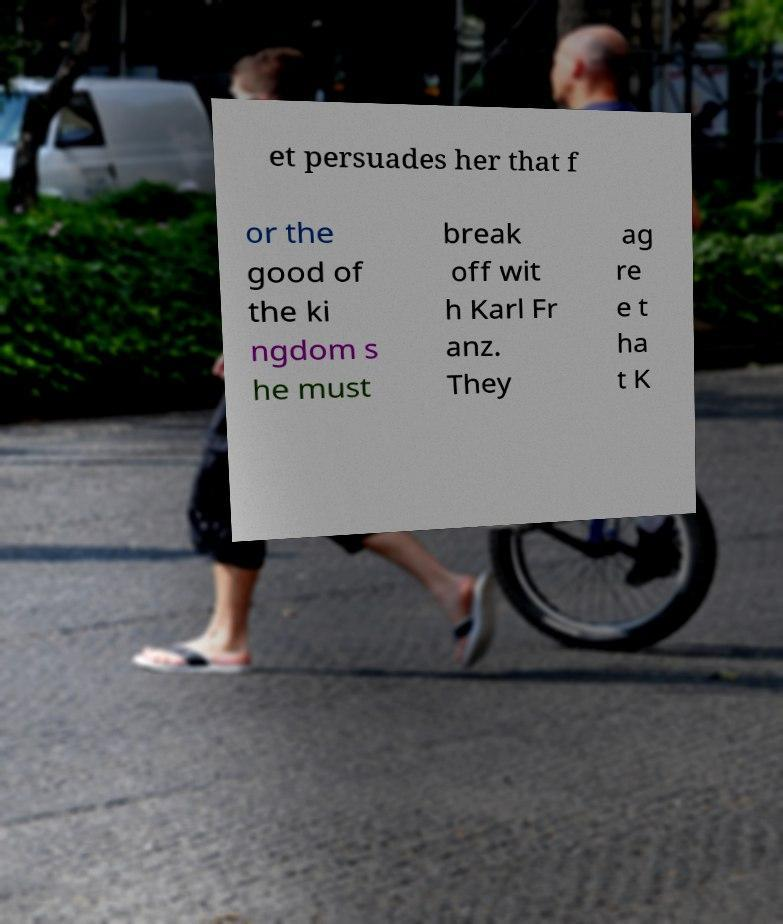Can you accurately transcribe the text from the provided image for me? et persuades her that f or the good of the ki ngdom s he must break off wit h Karl Fr anz. They ag re e t ha t K 